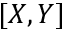Convert formula to latex. <formula><loc_0><loc_0><loc_500><loc_500>[ X , Y ]</formula> 